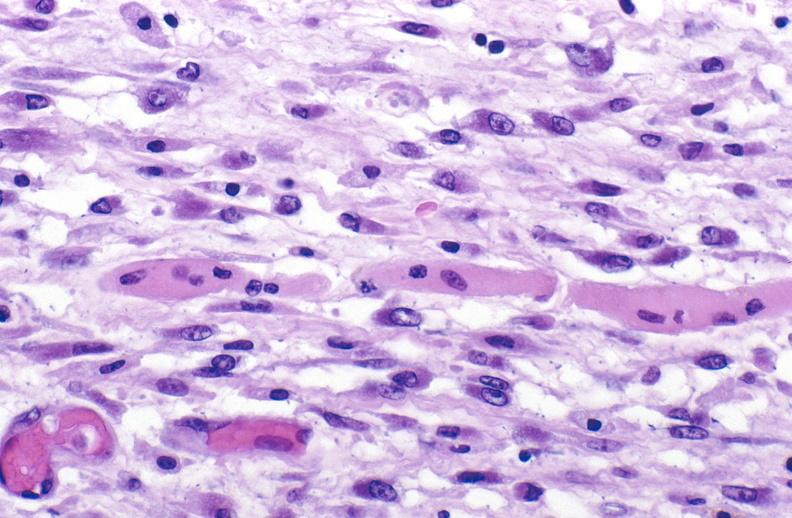what does this image show?
Answer the question using a single word or phrase. Tracheotomy site 